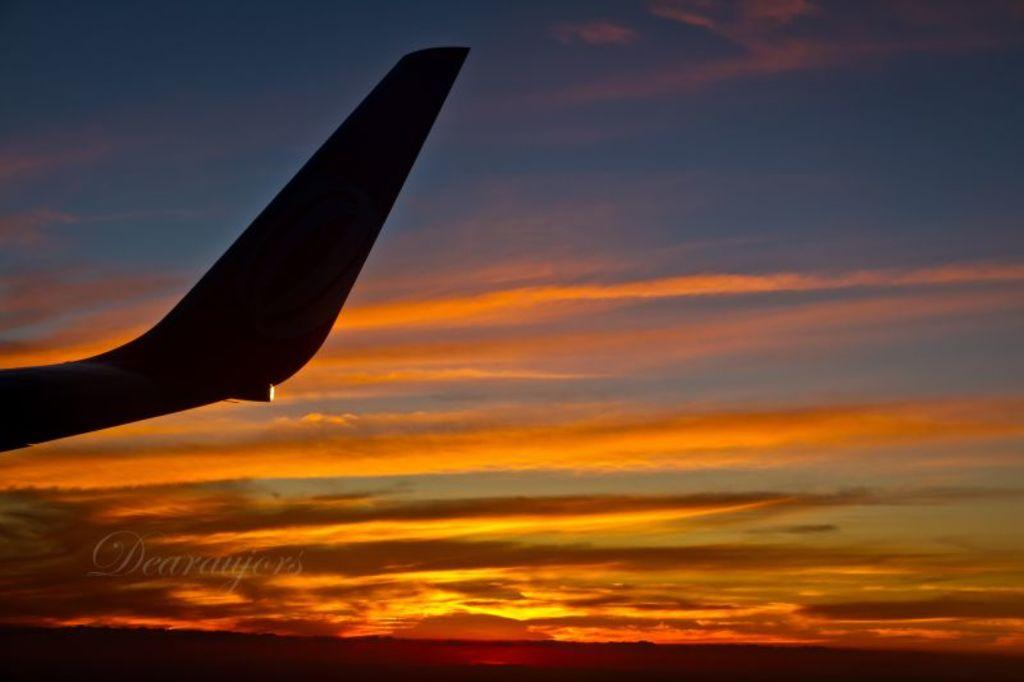<image>
Provide a brief description of the given image. Dearaujors took a photo of a sunset and an airplane. 